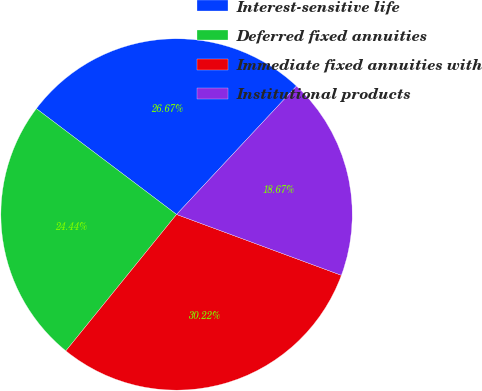Convert chart. <chart><loc_0><loc_0><loc_500><loc_500><pie_chart><fcel>Interest-sensitive life<fcel>Deferred fixed annuities<fcel>Immediate fixed annuities with<fcel>Institutional products<nl><fcel>26.67%<fcel>24.44%<fcel>30.22%<fcel>18.67%<nl></chart> 